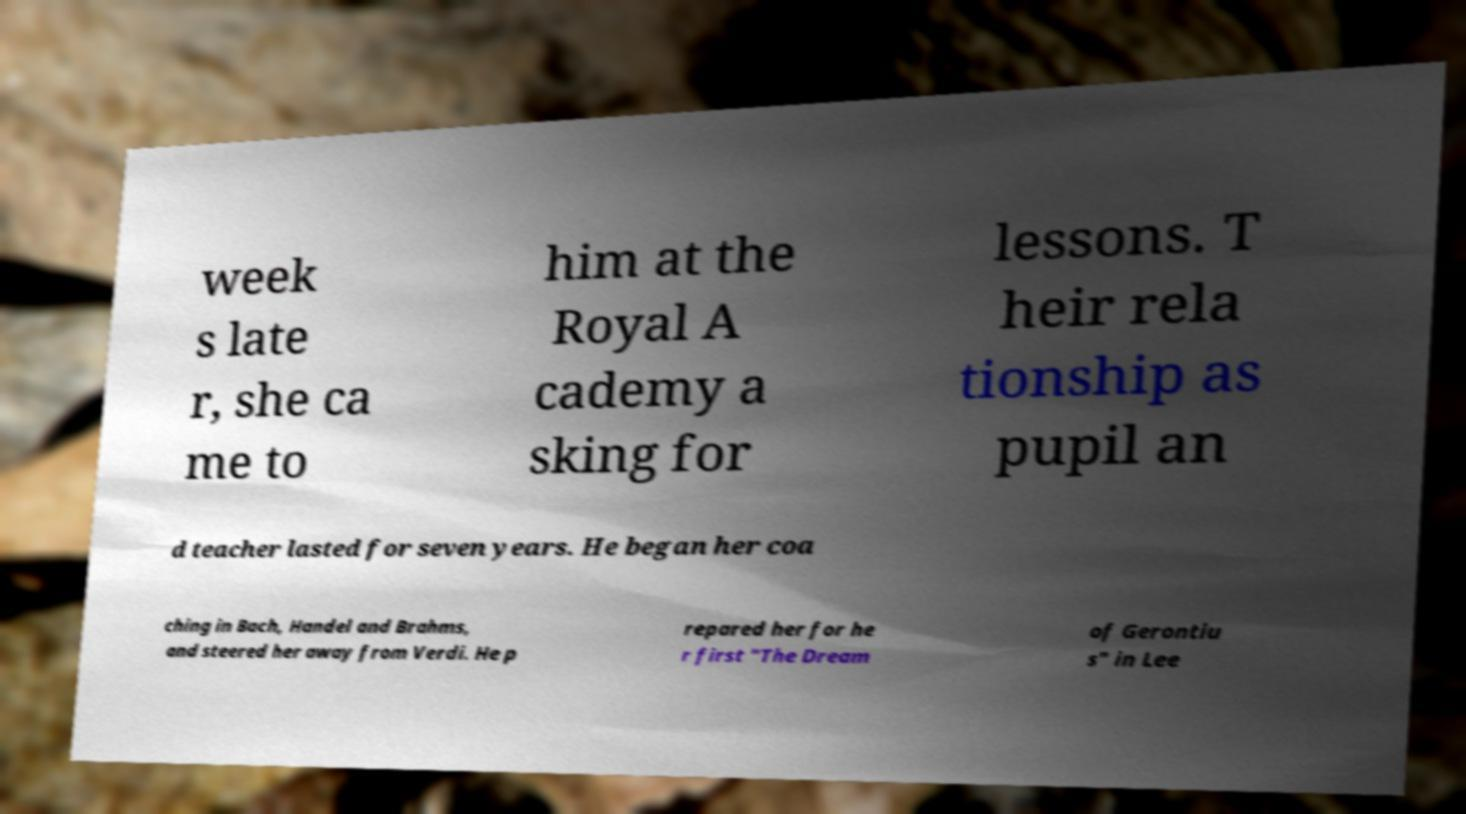What messages or text are displayed in this image? I need them in a readable, typed format. week s late r, she ca me to him at the Royal A cademy a sking for lessons. T heir rela tionship as pupil an d teacher lasted for seven years. He began her coa ching in Bach, Handel and Brahms, and steered her away from Verdi. He p repared her for he r first "The Dream of Gerontiu s" in Lee 